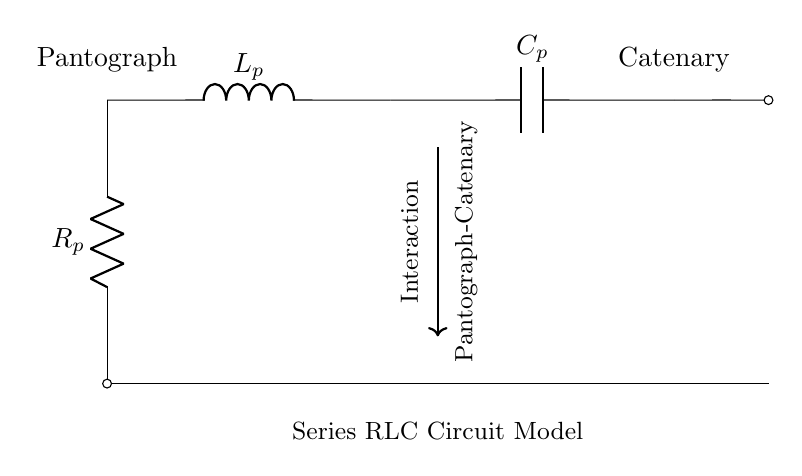What components are included in this circuit? The circuit diagram includes a resistor, an inductor, and a capacitor, labeled as R, L, and C respectively.
Answer: Resistor, Inductor, Capacitor What does the arrow in the diagram represent? The arrow indicates the direction of interaction between the pantograph and catenary, which is crucial for understanding power distribution.
Answer: Interaction direction What is the role of the resistor in this RLC circuit? The resistor in this series RLC circuit dissipates energy in the form of heat and affects the damping of oscillations and transient responses.
Answer: Damping What is the relationship between the components in this series RLC circuit? In a series RLC circuit, the inductor and capacitor together store energy, while the resistor dissipates it. This affects the overall behavior of the circuit during oscillations and steady states.
Answer: Energy storage and dissipation How does the pantograph interact with the catenary according to this model? The pantograph interacts with the catenary to form an electrical connection, which is modeled by the series RLC circuit to analyze dynamics and impedance. This improves understanding of the reliability of power supply and performance of the train systems.
Answer: Electrical connection What would happen to the circuit if the capacitor failed? If the capacitor fails, it would disrupt energy storage in the circuit, leading to increased oscillations and reduced performance in terms of filtering and signal stability. This could jeopardize the efficiency of the pantograph-catenary system.
Answer: Disrupted energy storage What is the significance of this circuit model in relation to electric trains? This model helps to visualize and analyze the interactions between pantographs and catenaries, ensuring efficient power transfer and minimizing wear and tear in train operations.
Answer: Efficient power transfer 